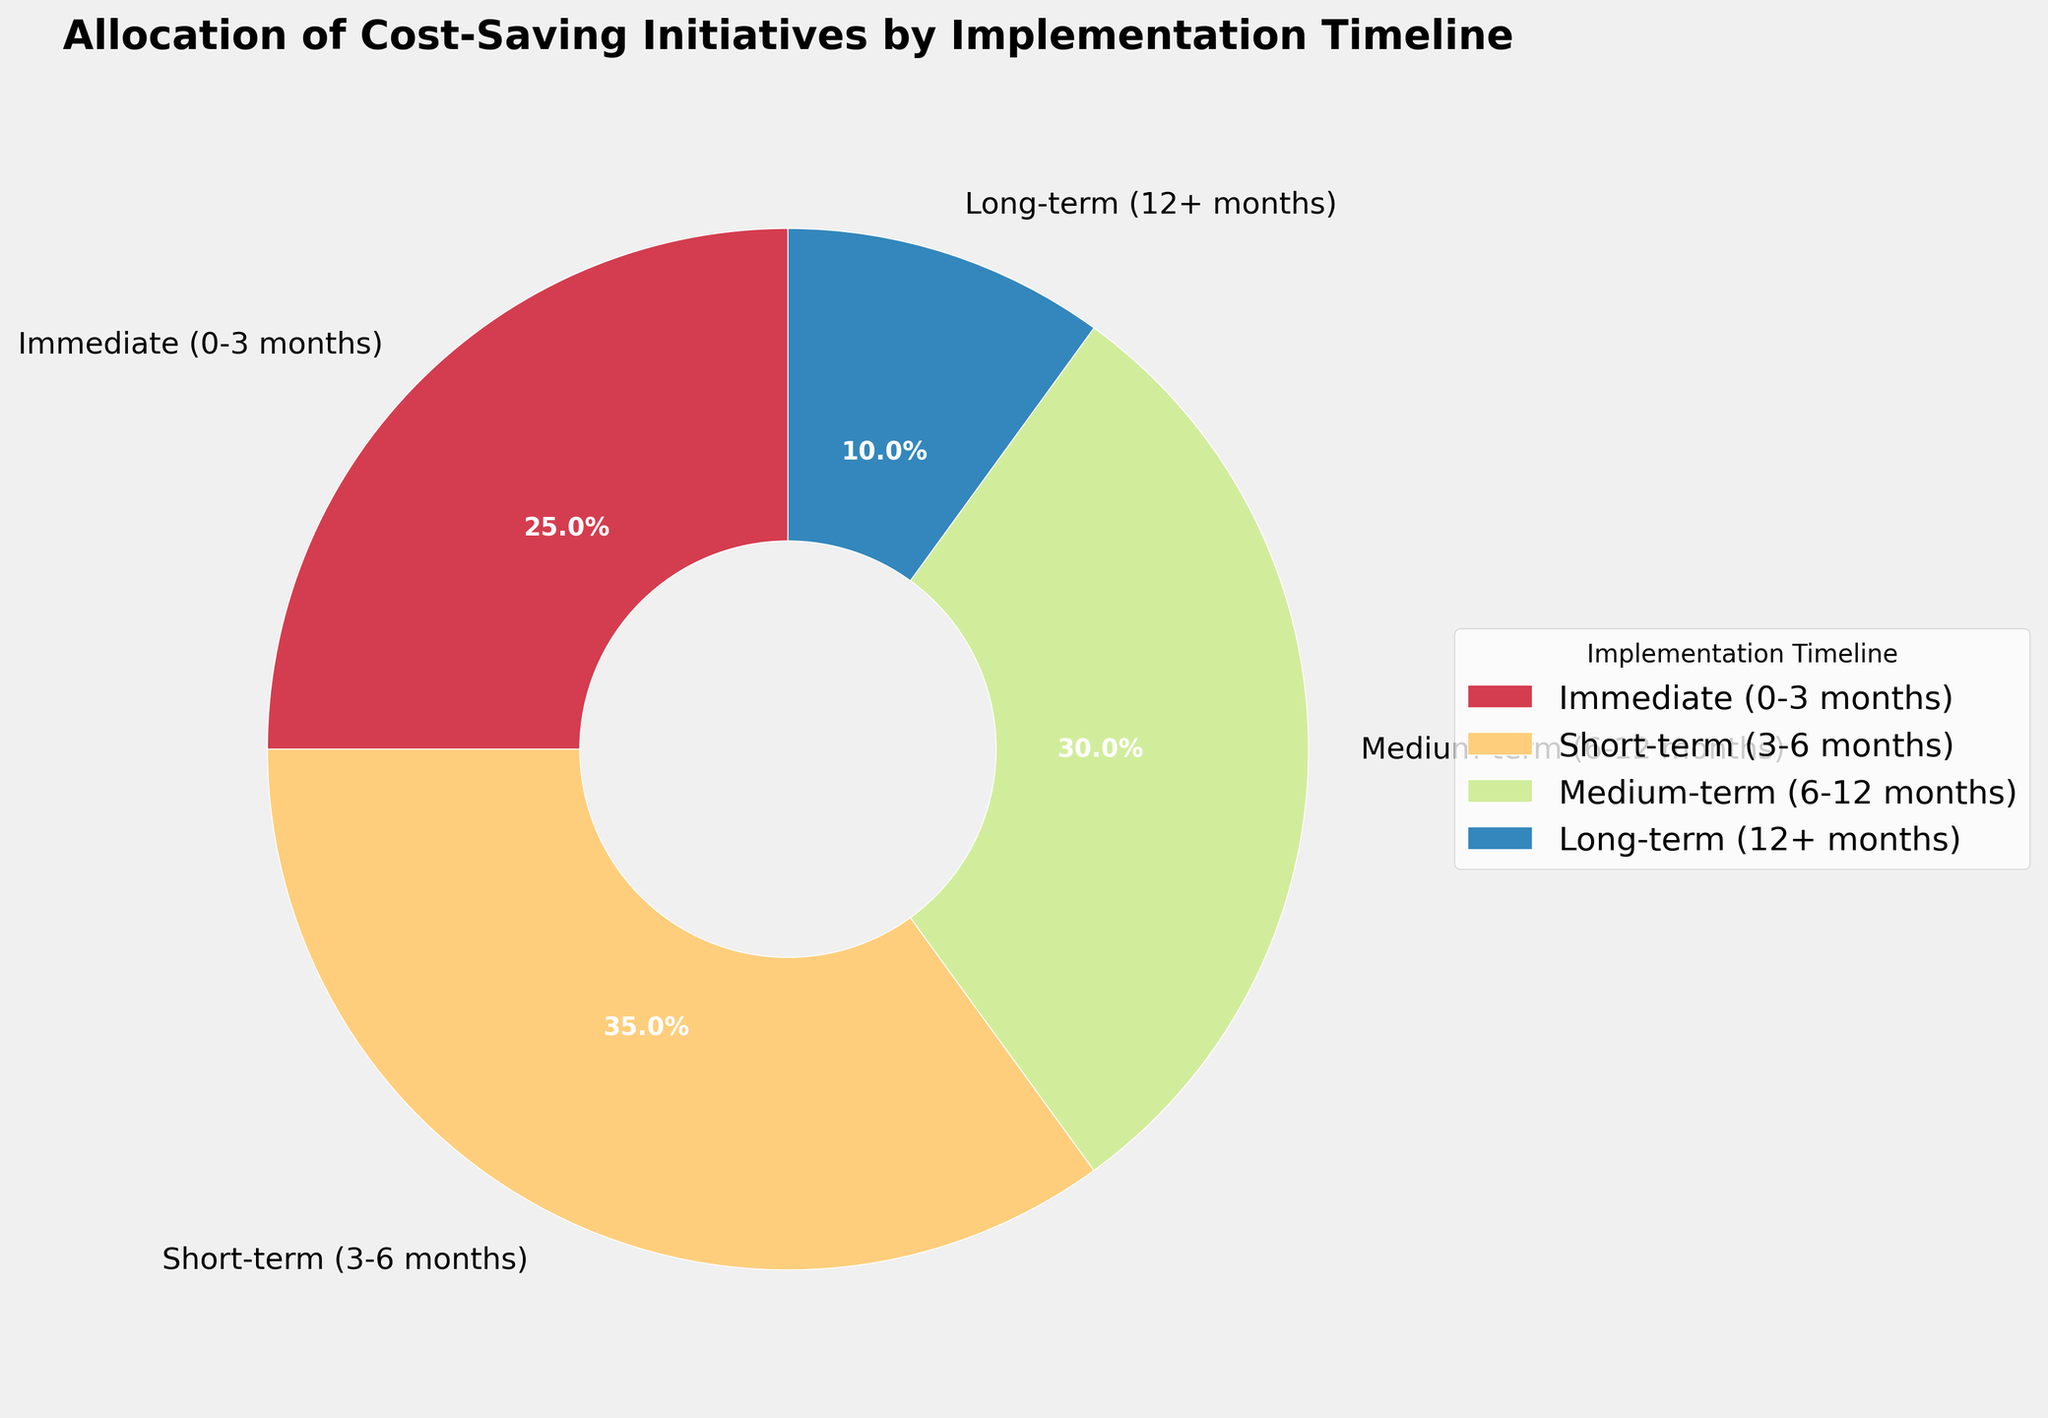Which implementation timeline has the highest proportion of cost-saving initiatives? The slice labeled "Short-term (3-6 months)" shows 35%, which is the highest proportion compared to the other timelines.
Answer: Short-term (3-6 months) What is the total percentage of cost-saving initiatives planned for implementation within 6 months? The sum of the "Immediate (0-3 months)" at 25% and "Short-term (3-6 months)" at 35% gives a total of 25 + 35 = 60%.
Answer: 60% Which implementation timeline has the smallest percentage allocation, and what is that percentage? The slice labeled "Long-term (12+ months)" shows 10%, which is the smallest percentage.
Answer: Long-term (12+ months), 10% Compare the proportions of medium-term (6-12 months) and long-term (12+ months) initiatives. Which is greater and by how much? The medium-term (6-12 months) is 30% while the long-term (12+ months) is 10%. So, 30% - 10% = 20%. Medium-term is greater by 20%.
Answer: Medium-term is greater by 20% How much larger is the percentage of immediate (0-3 months) initiatives compared to long-term (12+ months) initiatives? The immediate (0-3 months) initiatives constitute 25%, while long-term (12+ months) constitute 10%. The difference is 25 - 10 = 15%.
Answer: 15% What is the combined percentage of medium-term and long-term initiatives? The medium-term (6-12 months) is 30%, and the long-term (12+ months) is 10%. The total is 30 + 10 = 40%.
Answer: 40% Is the percentage allocation for short-term (3-6 months) initiatives greater than the combined immediate (0-3 months) and long-term (12+ months) initiatives? The short-term (3-6 months) initiatives are 35%. The combined immediate (0-3 months) and long-term (12+ months) is 25% + 10% = 35%. So they are equal.
Answer: No What color represents the short-term (3-6 months) initiatives in the pie chart? Observing the pie chart, the short-term (3-6 months) section is associated with a specific color within the color gradient used for the wedges. Without visual representation here, refer to the provided figure for the exact shade.
Answer: Refer to chart 